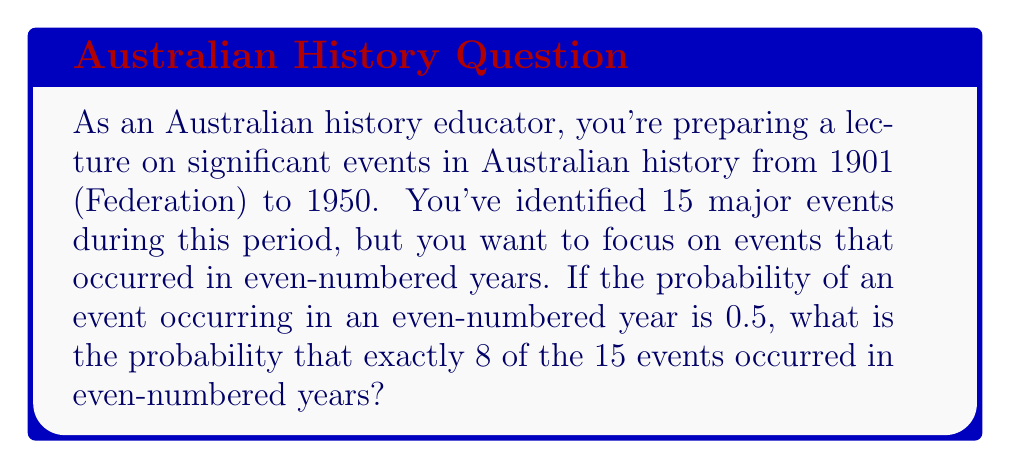Can you solve this math problem? To solve this problem, we need to use the binomial probability distribution. The binomial distribution is used when we have a fixed number of independent trials (in this case, 15 events), each with the same probability of success (in this case, occurring in an even-numbered year).

Let's break down the problem:

1. Total number of events: $n = 15$
2. Probability of an event occurring in an even-numbered year: $p = 0.5$
3. Number of events we want to occur in even-numbered years: $k = 8$

The binomial probability formula is:

$$ P(X = k) = \binom{n}{k} p^k (1-p)^{n-k} $$

Where:
- $\binom{n}{k}$ is the binomial coefficient, calculated as $\frac{n!}{k!(n-k)!}$
- $p^k$ is the probability of success raised to the power of the number of successes
- $(1-p)^{n-k}$ is the probability of failure raised to the power of the number of failures

Let's calculate each part:

1. $\binom{15}{8} = \frac{15!}{8!(15-8)!} = \frac{15!}{8!7!} = 6435$
2. $p^k = 0.5^8 = \frac{1}{256}$
3. $(1-p)^{n-k} = 0.5^7 = \frac{1}{128}$

Now, let's put it all together:

$$ P(X = 8) = 6435 \cdot \frac{1}{256} \cdot \frac{1}{128} = \frac{6435}{32768} \approx 0.1964 $$
Answer: The probability that exactly 8 out of the 15 significant events occurred in even-numbered years is $\frac{6435}{32768}$ or approximately 0.1964 (19.64%). 